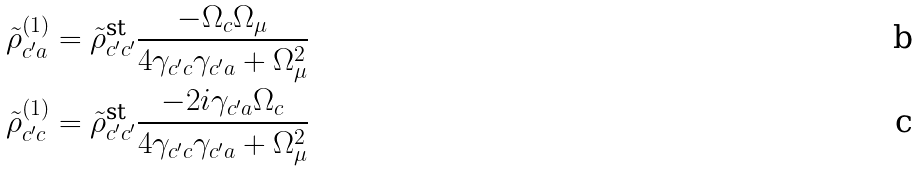<formula> <loc_0><loc_0><loc_500><loc_500>\tilde { \rho } ^ { ( 1 ) } _ { c ^ { \prime } a } & = \tilde { \rho } ^ { \text {st} } _ { c ^ { \prime } c ^ { \prime } } \frac { - \Omega _ { c } \Omega _ { \mu } } { 4 \gamma _ { c ^ { \prime } c } \gamma _ { c ^ { \prime } a } + \Omega _ { \mu } ^ { 2 } } \\ \tilde { \rho } ^ { ( 1 ) } _ { c ^ { \prime } c } & = \tilde { \rho } ^ { \text {st} } _ { c ^ { \prime } c ^ { \prime } } \frac { - 2 i \gamma _ { c ^ { \prime } a } \Omega _ { c } } { 4 \gamma _ { c ^ { \prime } c } \gamma _ { c ^ { \prime } a } + \Omega _ { \mu } ^ { 2 } }</formula> 